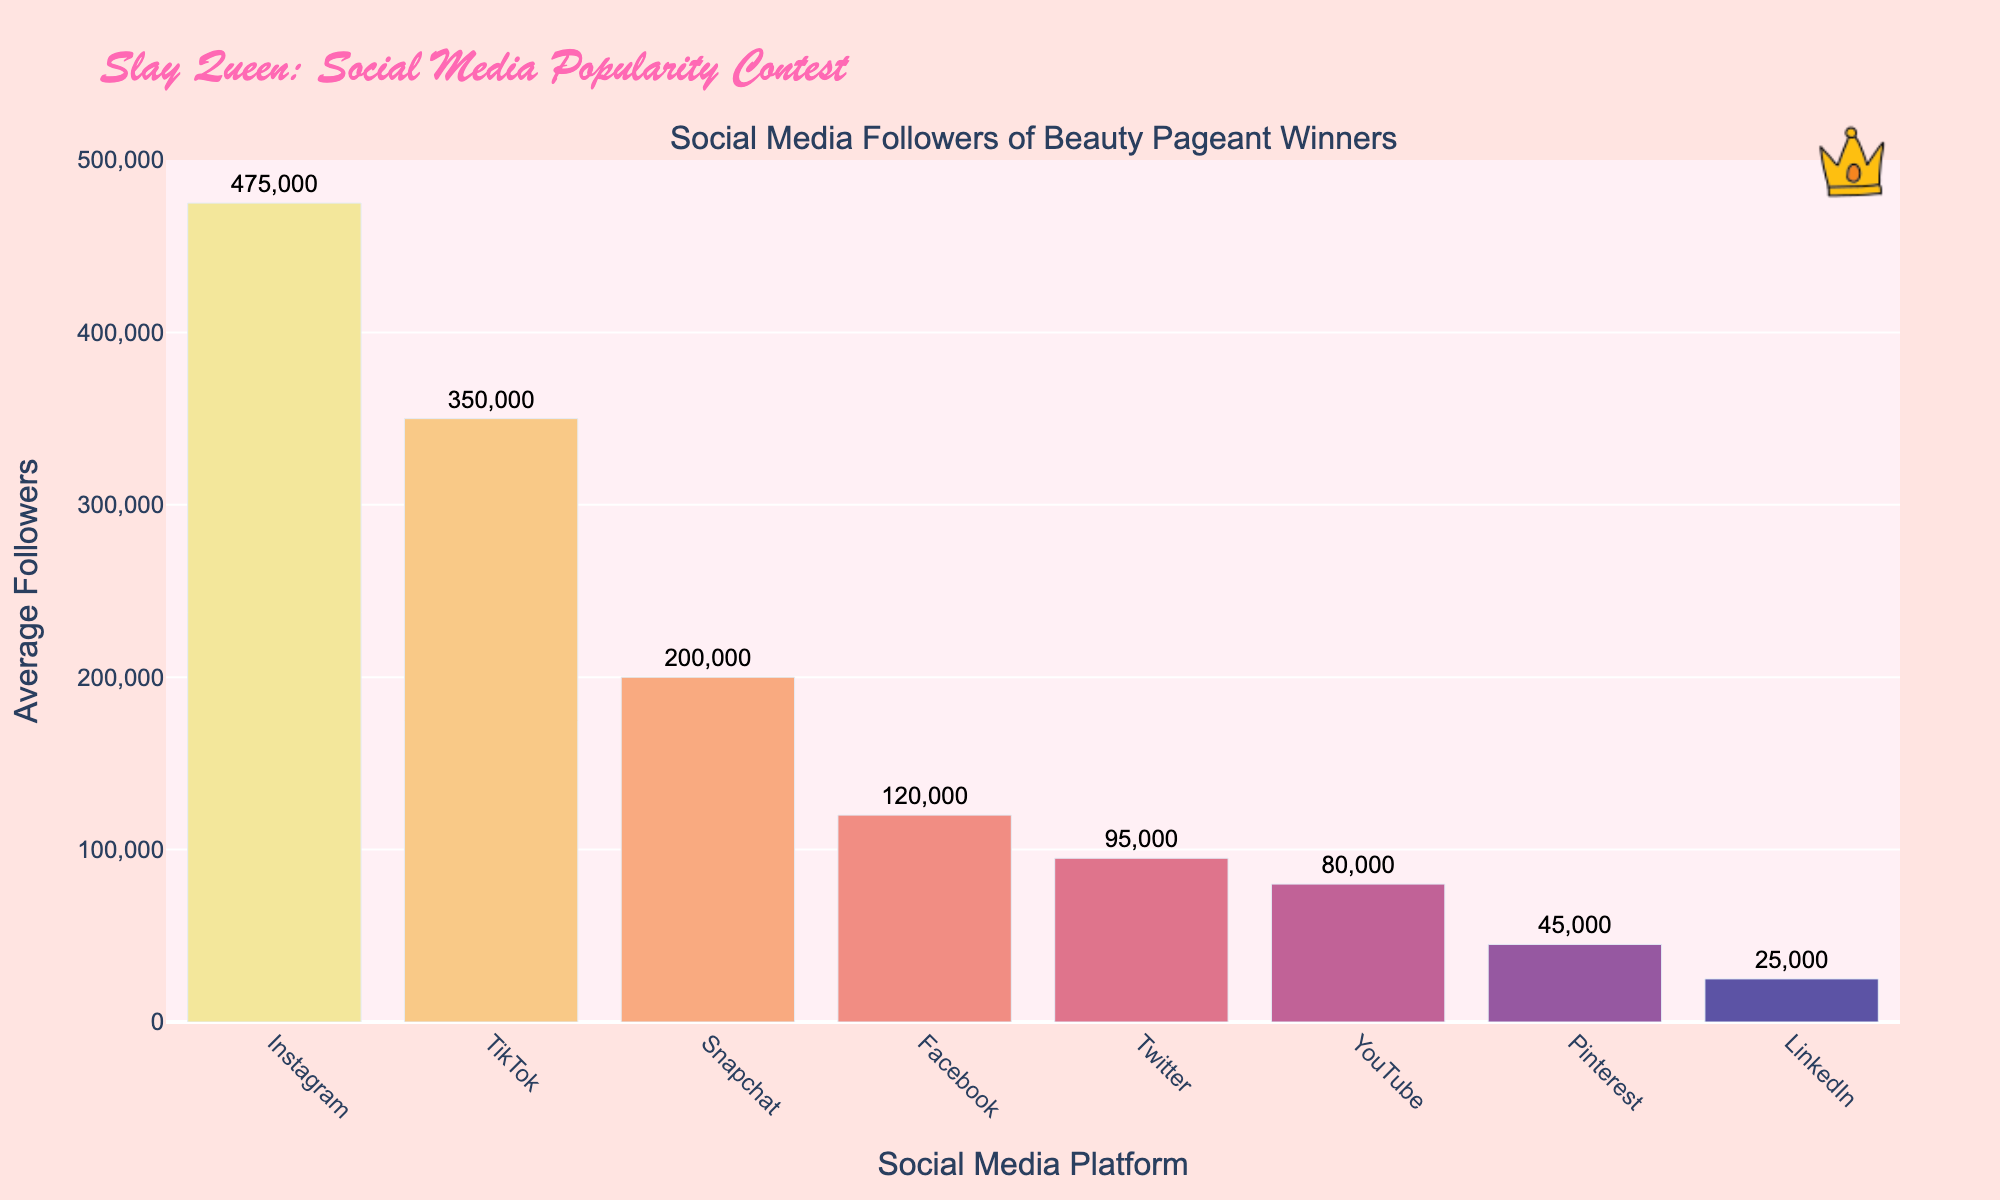Which platform has the highest average followers? By looking at the heights of the bars, the Instagram bar is the tallest, indicating it has the highest average followers.
Answer: Instagram How many average followers does the TikTok platform have compared to LinkedIn? The followers for TikTok are 350,000, and for LinkedIn, they are 25,000. Subtract 25,000 from 350,000. This difference is 325,000.
Answer: 325,000 What is the total number of average followers for Facebook, Pinterest, and Snapchat combined? Adding the average followers: Facebook (120,000) + Pinterest (45,000) + Snapchat (200,000) results in 365,000.
Answer: 365,000 Which social media platforms have more average followers than YouTube but less than TikTok? YouTube has 80,000, and TikTok has 350,000 followers. The platforms satisfying the criteria are Facebook with 120,000 and Twitter with 95,000 followers.
Answer: Facebook and Twitter Which platform has the least average followers, and how does it compare to Pinterest? The LinkedIn bar is the shortest, showing it has the least average followers at 25,000. Pinterest has 45,000 followers, so the difference is 20,000.
Answer: LinkedIn, 20,000 What is the average number of followers across all platforms? Summing the average followers for all platforms (475,000 + 350,000 + 120,000 + 95,000 + 80,000 + 45,000 + 25,000 + 200,000) gives 1,390,000. Dividing by 8 platforms gives an average of 173,750.
Answer: 173,750 Which platform’s followers are closest in number to Snapchat’s followers? Comparing the average followers of Snapchat (200,000) to the nearest figures, Twitter has 95,000, and Facebook has 120,000. The closest is Facebook with a difference of 80,000.
Answer: Facebook How many platforms have more than 100,000 average followers? The platforms are Instagram (475,000), TikTok (350,000), Facebook (120,000), and Snapchat (200,000), which makes a total of 4.
Answer: 4 